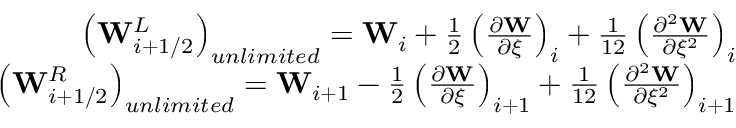<formula> <loc_0><loc_0><loc_500><loc_500>\begin{array} { r } { \left ( W _ { i + 1 / 2 } ^ { L } \right ) _ { u n l i m i t e d } = W _ { i } + \frac { 1 } { 2 } \left ( \frac { \partial W } { \partial \xi } \right ) _ { i } + \frac { 1 } { 1 2 } \left ( \frac { \partial ^ { 2 } W } { \partial \xi ^ { 2 } } \right ) _ { i } } \\ { \left ( W _ { i + 1 / 2 } ^ { R } \right ) _ { u n l i m i t e d } = W _ { i + 1 } - \frac { 1 } { 2 } \left ( \frac { \partial W } { \partial \xi } \right ) _ { i + 1 } + \frac { 1 } { 1 2 } \left ( \frac { \partial ^ { 2 } W } { \partial \xi ^ { 2 } } \right ) _ { i + 1 } } \end{array}</formula> 